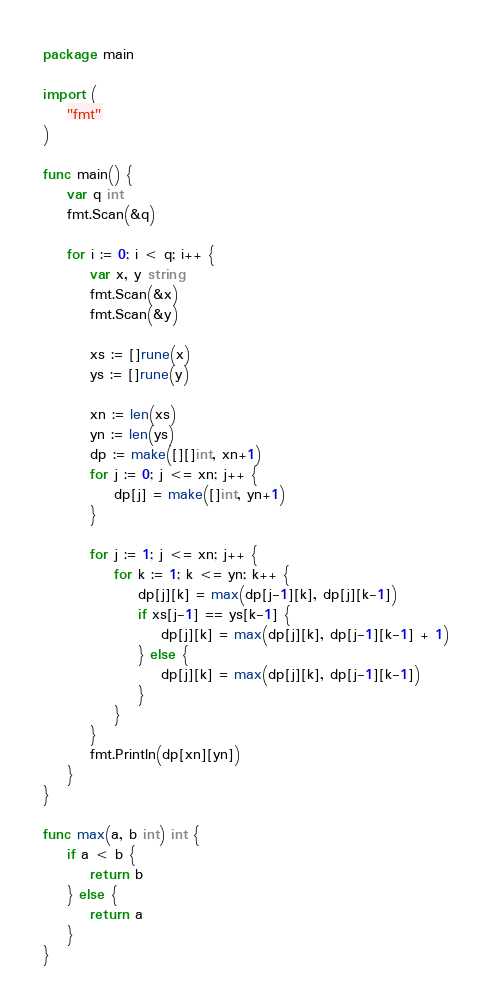<code> <loc_0><loc_0><loc_500><loc_500><_Go_>package main

import (
	"fmt"
)

func main() {
	var q int
	fmt.Scan(&q)

	for i := 0; i < q; i++ {
		var x, y string
		fmt.Scan(&x)
		fmt.Scan(&y)

		xs := []rune(x)
		ys := []rune(y)

		xn := len(xs)
		yn := len(ys)
		dp := make([][]int, xn+1)
		for j := 0; j <= xn; j++ {
			dp[j] = make([]int, yn+1)
		}

		for j := 1; j <= xn; j++ {
			for k := 1; k <= yn; k++ {
				dp[j][k] = max(dp[j-1][k], dp[j][k-1])
				if xs[j-1] == ys[k-1] {
					dp[j][k] = max(dp[j][k], dp[j-1][k-1] + 1)
				} else {
					dp[j][k] = max(dp[j][k], dp[j-1][k-1])
				}
			}
		}
		fmt.Println(dp[xn][yn])
	}
}

func max(a, b int) int {
	if a < b {
		return b
	} else {
		return a
	}
}

</code> 